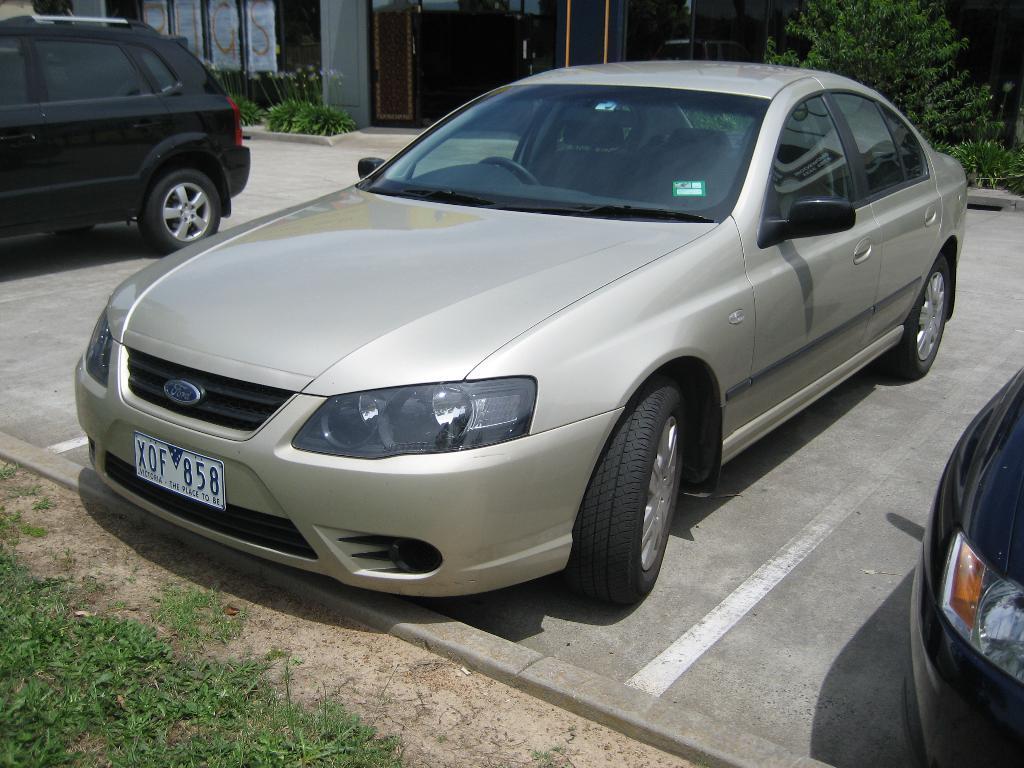Could you give a brief overview of what you see in this image? In this image we can see these cars are parked on road. Here we can see the grass, shrubs, doors and the building in the background. 